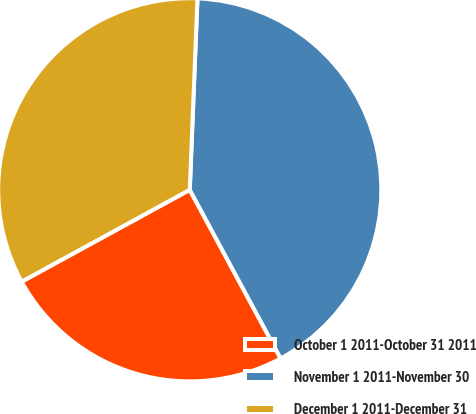<chart> <loc_0><loc_0><loc_500><loc_500><pie_chart><fcel>October 1 2011-October 31 2011<fcel>November 1 2011-November 30<fcel>December 1 2011-December 31<nl><fcel>24.91%<fcel>41.49%<fcel>33.6%<nl></chart> 